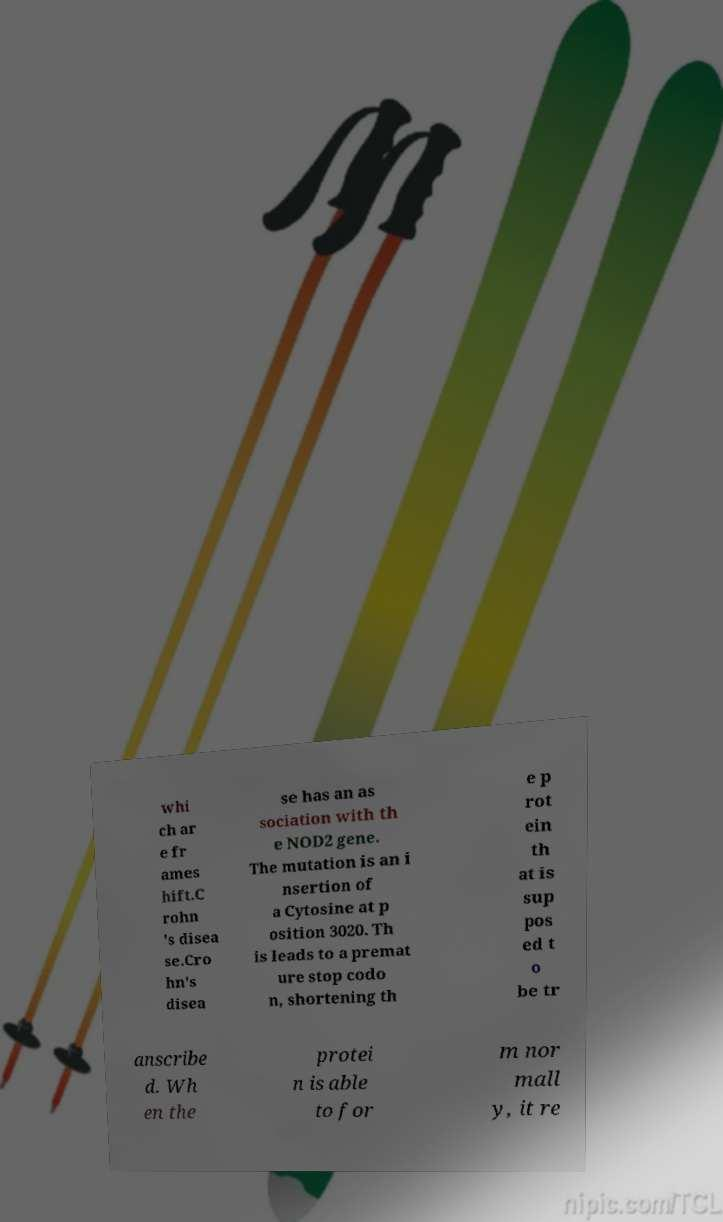Please identify and transcribe the text found in this image. whi ch ar e fr ames hift.C rohn 's disea se.Cro hn's disea se has an as sociation with th e NOD2 gene. The mutation is an i nsertion of a Cytosine at p osition 3020. Th is leads to a premat ure stop codo n, shortening th e p rot ein th at is sup pos ed t o be tr anscribe d. Wh en the protei n is able to for m nor mall y, it re 